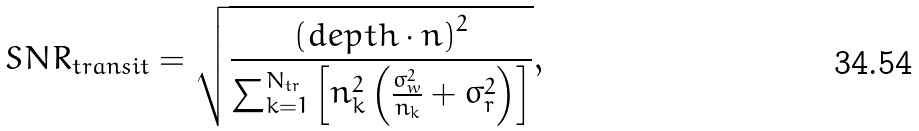<formula> <loc_0><loc_0><loc_500><loc_500>S N R _ { t r a n s i t } = \sqrt { \frac { \left ( d e p t h \cdot n \right ) ^ { 2 } } { \sum ^ { N _ { t r } } _ { k = 1 } \left [ n ^ { 2 } _ { k } \left ( \frac { \sigma ^ { 2 } _ { w } } { n _ { k } } + \sigma ^ { 2 } _ { r } \right ) \right ] } } ,</formula> 